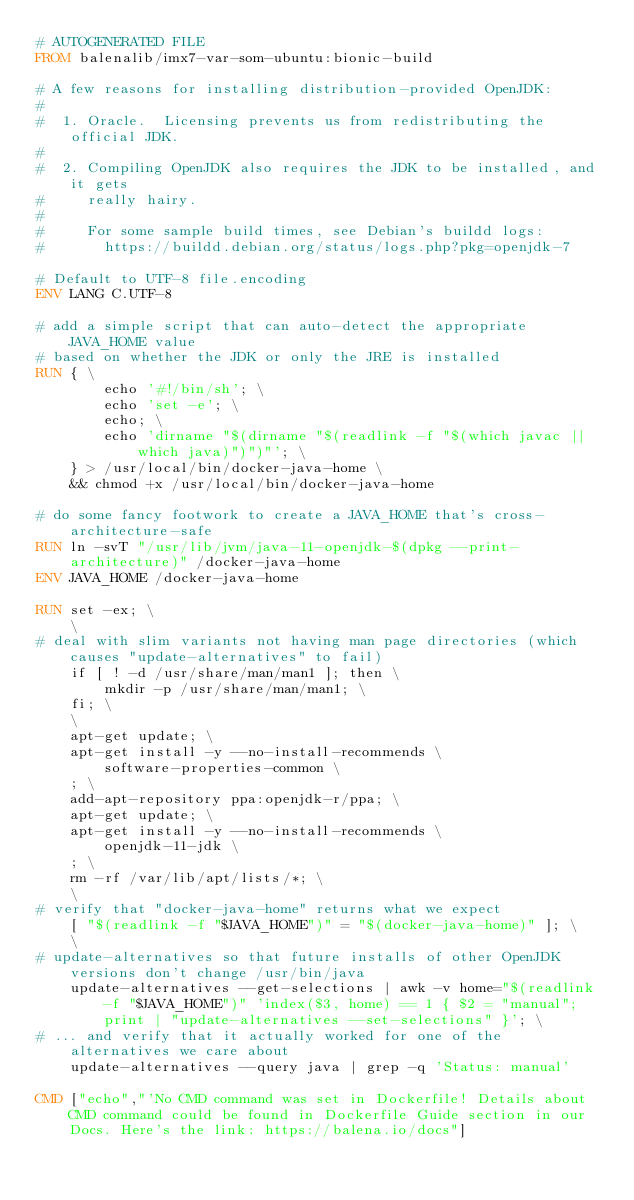Convert code to text. <code><loc_0><loc_0><loc_500><loc_500><_Dockerfile_># AUTOGENERATED FILE
FROM balenalib/imx7-var-som-ubuntu:bionic-build

# A few reasons for installing distribution-provided OpenJDK:
#
#  1. Oracle.  Licensing prevents us from redistributing the official JDK.
#
#  2. Compiling OpenJDK also requires the JDK to be installed, and it gets
#     really hairy.
#
#     For some sample build times, see Debian's buildd logs:
#       https://buildd.debian.org/status/logs.php?pkg=openjdk-7

# Default to UTF-8 file.encoding
ENV LANG C.UTF-8

# add a simple script that can auto-detect the appropriate JAVA_HOME value
# based on whether the JDK or only the JRE is installed
RUN { \
		echo '#!/bin/sh'; \
		echo 'set -e'; \
		echo; \
		echo 'dirname "$(dirname "$(readlink -f "$(which javac || which java)")")"'; \
	} > /usr/local/bin/docker-java-home \
	&& chmod +x /usr/local/bin/docker-java-home

# do some fancy footwork to create a JAVA_HOME that's cross-architecture-safe
RUN ln -svT "/usr/lib/jvm/java-11-openjdk-$(dpkg --print-architecture)" /docker-java-home
ENV JAVA_HOME /docker-java-home

RUN set -ex; \
	\
# deal with slim variants not having man page directories (which causes "update-alternatives" to fail)
	if [ ! -d /usr/share/man/man1 ]; then \
		mkdir -p /usr/share/man/man1; \
	fi; \
	\
	apt-get update; \
	apt-get install -y --no-install-recommends \
		software-properties-common \
	; \
	add-apt-repository ppa:openjdk-r/ppa; \
	apt-get update; \
	apt-get install -y --no-install-recommends \
		openjdk-11-jdk \
	; \
	rm -rf /var/lib/apt/lists/*; \
	\
# verify that "docker-java-home" returns what we expect
	[ "$(readlink -f "$JAVA_HOME")" = "$(docker-java-home)" ]; \
	\
# update-alternatives so that future installs of other OpenJDK versions don't change /usr/bin/java
	update-alternatives --get-selections | awk -v home="$(readlink -f "$JAVA_HOME")" 'index($3, home) == 1 { $2 = "manual"; print | "update-alternatives --set-selections" }'; \
# ... and verify that it actually worked for one of the alternatives we care about
	update-alternatives --query java | grep -q 'Status: manual'

CMD ["echo","'No CMD command was set in Dockerfile! Details about CMD command could be found in Dockerfile Guide section in our Docs. Here's the link: https://balena.io/docs"]</code> 